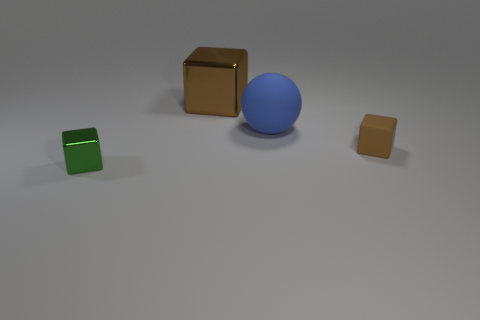Add 1 large brown blocks. How many objects exist? 5 Subtract all spheres. How many objects are left? 3 Add 3 tiny rubber blocks. How many tiny rubber blocks are left? 4 Add 2 cyan rubber cylinders. How many cyan rubber cylinders exist? 2 Subtract 0 cyan blocks. How many objects are left? 4 Subtract all shiny cubes. Subtract all small brown objects. How many objects are left? 1 